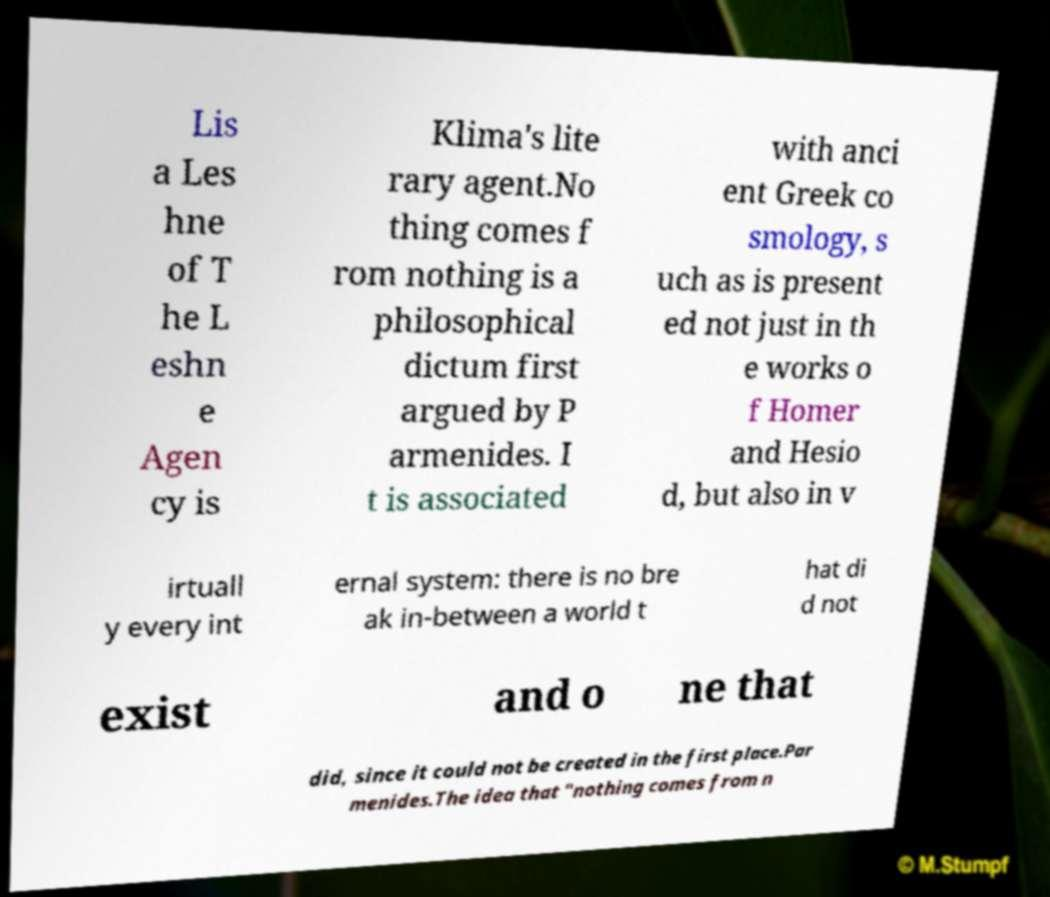Could you extract and type out the text from this image? Lis a Les hne of T he L eshn e Agen cy is Klima's lite rary agent.No thing comes f rom nothing is a philosophical dictum first argued by P armenides. I t is associated with anci ent Greek co smology, s uch as is present ed not just in th e works o f Homer and Hesio d, but also in v irtuall y every int ernal system: there is no bre ak in-between a world t hat di d not exist and o ne that did, since it could not be created in the first place.Par menides.The idea that "nothing comes from n 